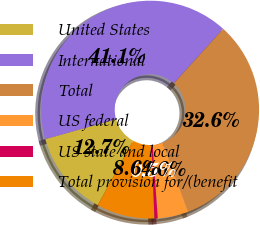Convert chart. <chart><loc_0><loc_0><loc_500><loc_500><pie_chart><fcel>United States<fcel>International<fcel>Total<fcel>US federal<fcel>US state and local<fcel>Total provision for/(benefit<nl><fcel>12.66%<fcel>41.06%<fcel>32.64%<fcel>4.55%<fcel>0.49%<fcel>8.6%<nl></chart> 